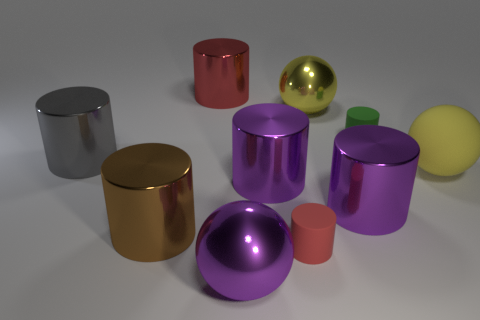There is another small matte object that is the same shape as the small red matte thing; what color is it?
Your answer should be very brief. Green. Does the matte cylinder that is behind the small red matte object have the same size as the red cylinder in front of the yellow metallic object?
Your answer should be compact. Yes. There is a brown cylinder; does it have the same size as the green rubber thing that is behind the big brown thing?
Your answer should be compact. No. What is the size of the matte sphere?
Provide a succinct answer. Large. There is a tiny object that is the same material as the tiny red cylinder; what color is it?
Offer a very short reply. Green. What number of large brown objects have the same material as the big gray cylinder?
Your response must be concise. 1. What number of objects are either matte balls or large shiny cylinders that are left of the big purple ball?
Your answer should be compact. 4. Are the red thing that is right of the red metal object and the brown cylinder made of the same material?
Offer a terse response. No. There is another thing that is the same size as the green rubber thing; what color is it?
Ensure brevity in your answer.  Red. Are there any other objects of the same shape as the large gray shiny thing?
Keep it short and to the point. Yes. 